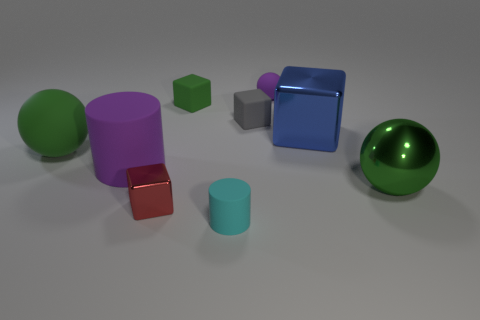Add 1 green metallic spheres. How many objects exist? 10 Subtract all blocks. How many objects are left? 5 Subtract 0 green cylinders. How many objects are left? 9 Subtract all purple metal cylinders. Subtract all small gray rubber objects. How many objects are left? 8 Add 9 red objects. How many red objects are left? 10 Add 1 yellow metallic cubes. How many yellow metallic cubes exist? 1 